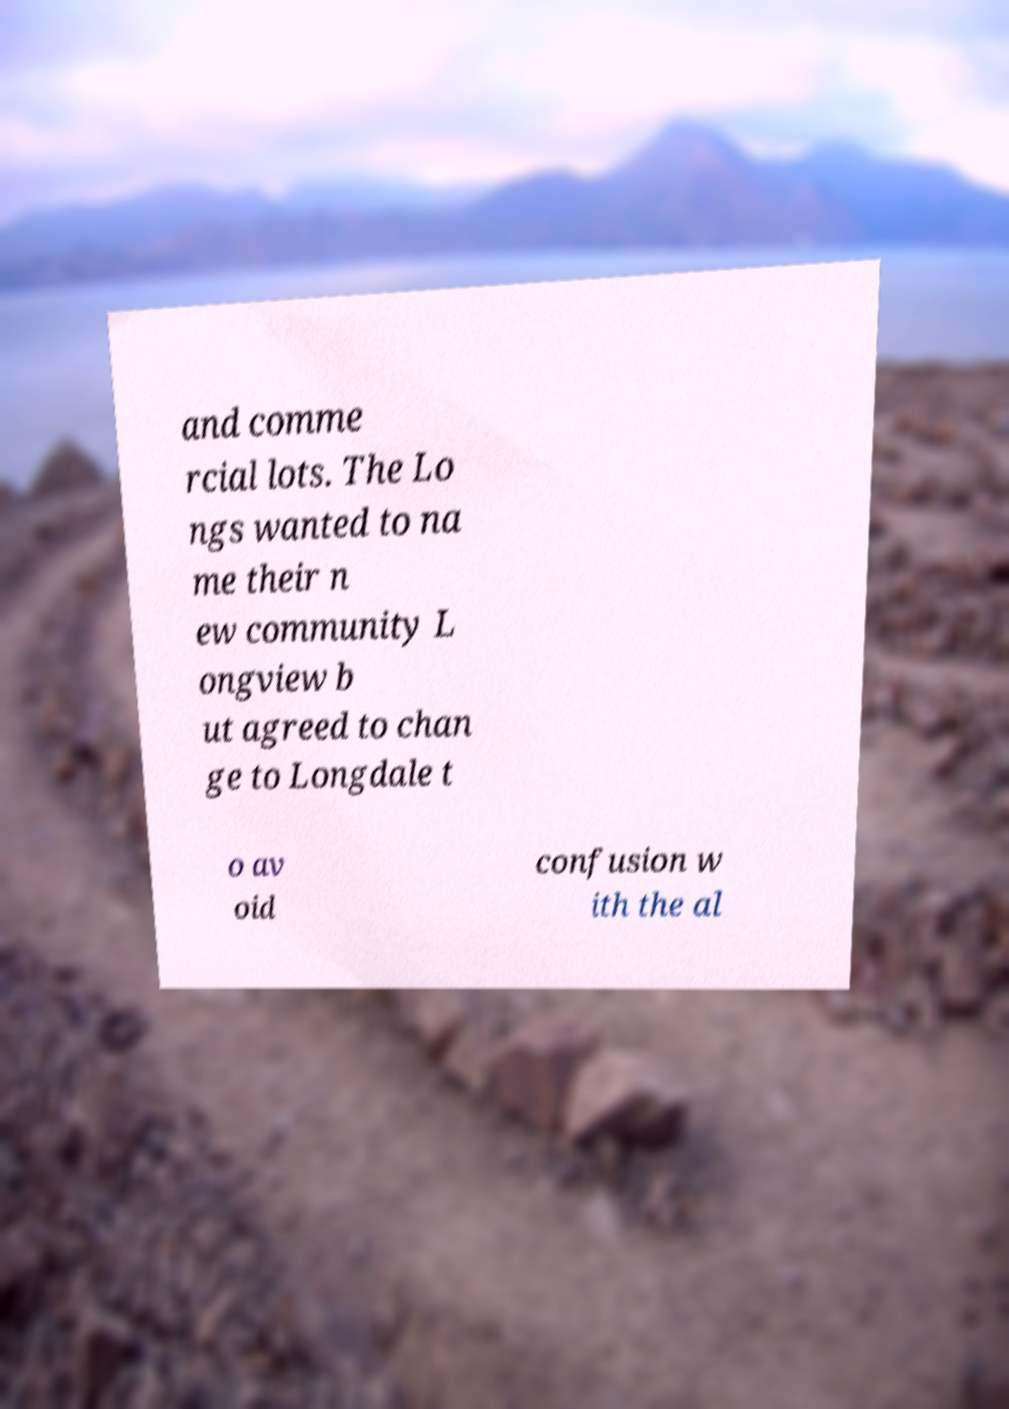There's text embedded in this image that I need extracted. Can you transcribe it verbatim? and comme rcial lots. The Lo ngs wanted to na me their n ew community L ongview b ut agreed to chan ge to Longdale t o av oid confusion w ith the al 